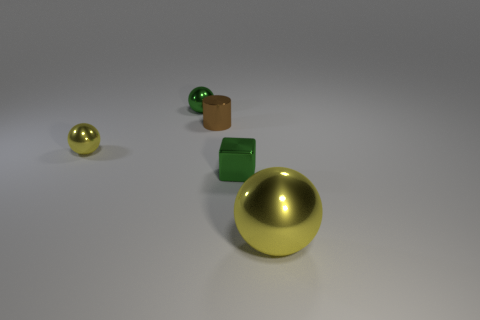Add 1 big blue rubber things. How many objects exist? 6 Subtract all spheres. How many objects are left? 2 Add 5 brown metallic objects. How many brown metallic objects exist? 6 Subtract 0 blue cubes. How many objects are left? 5 Subtract all small brown rubber balls. Subtract all large yellow metallic balls. How many objects are left? 4 Add 4 small brown cylinders. How many small brown cylinders are left? 5 